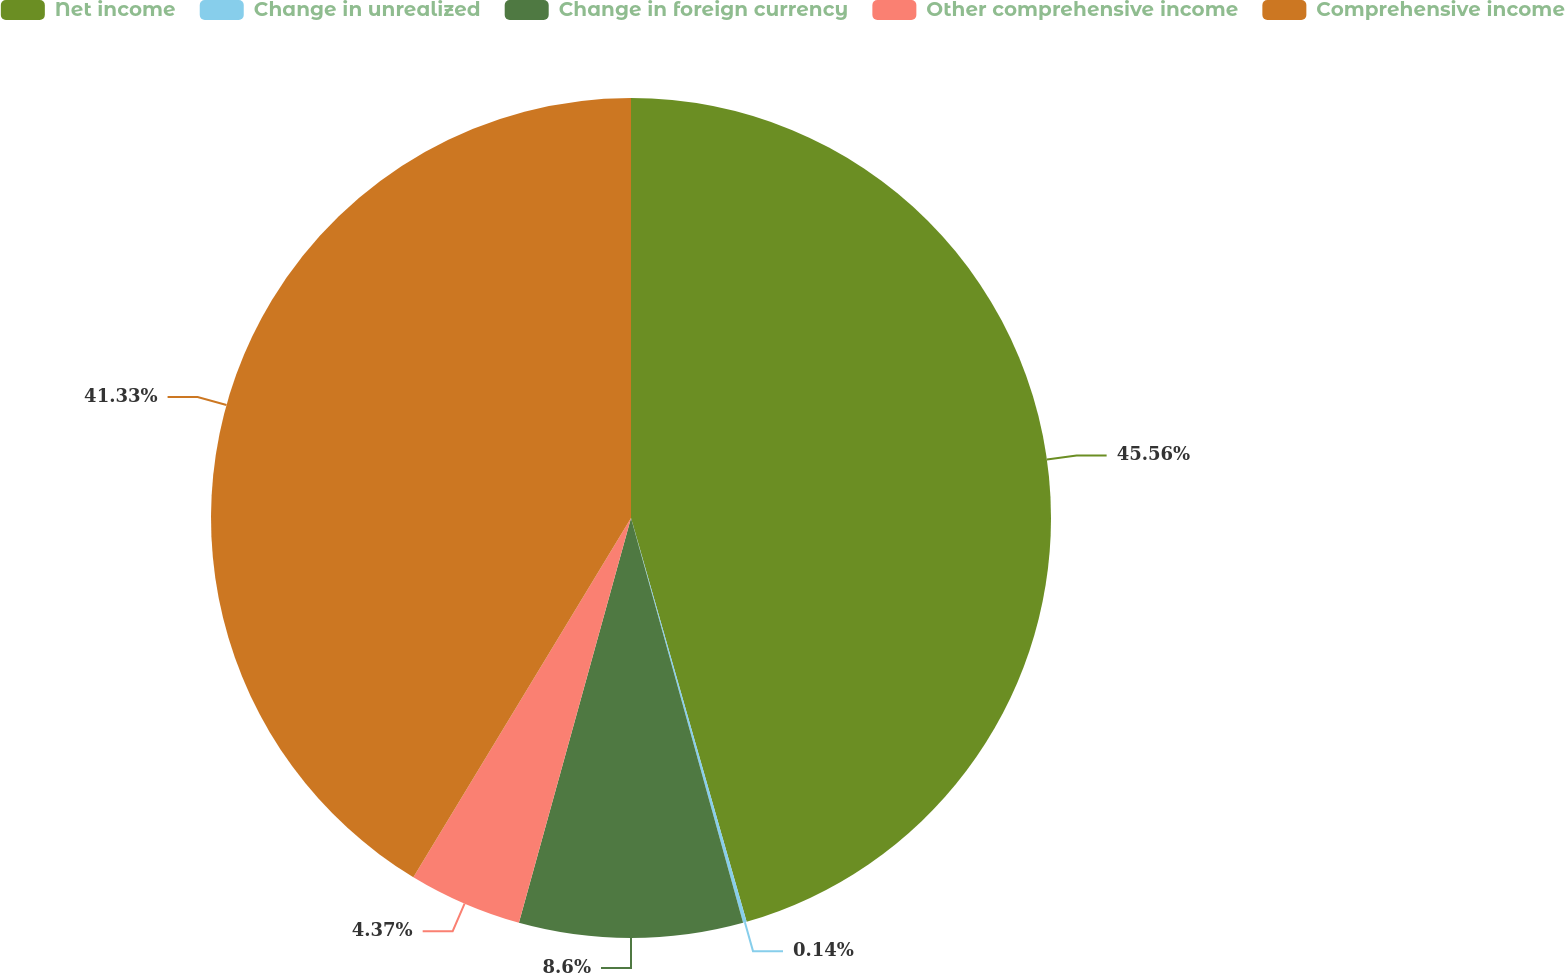Convert chart to OTSL. <chart><loc_0><loc_0><loc_500><loc_500><pie_chart><fcel>Net income<fcel>Change in unrealized<fcel>Change in foreign currency<fcel>Other comprehensive income<fcel>Comprehensive income<nl><fcel>45.56%<fcel>0.14%<fcel>8.6%<fcel>4.37%<fcel>41.33%<nl></chart> 